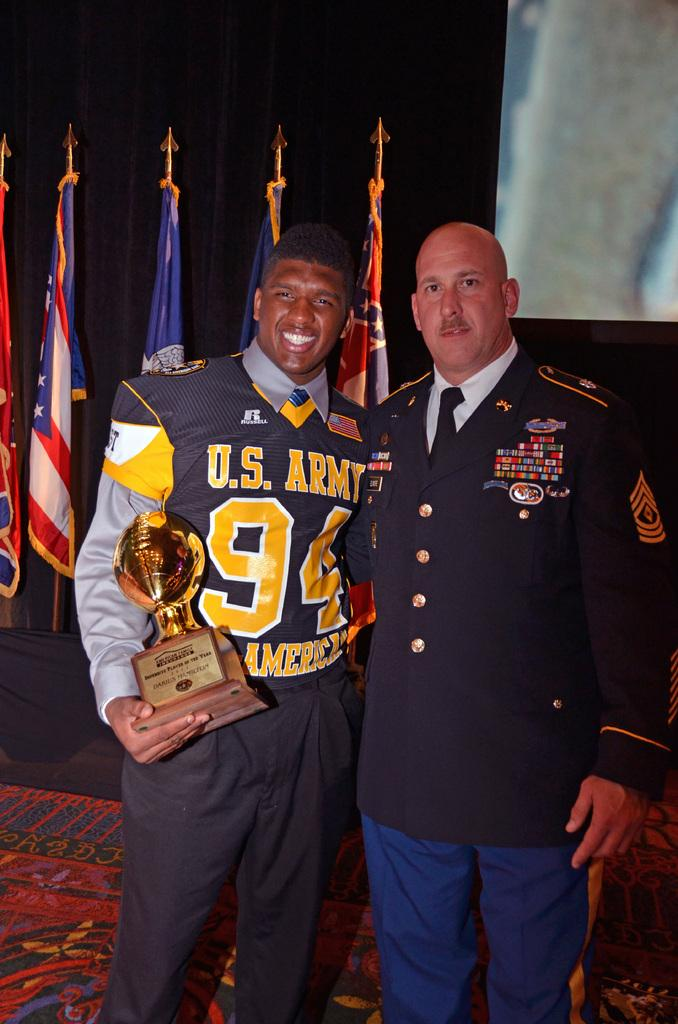<image>
Create a compact narrative representing the image presented. U.S. Army athlete # 94 receiving an award with his captain next to him, having an American shirt on. 